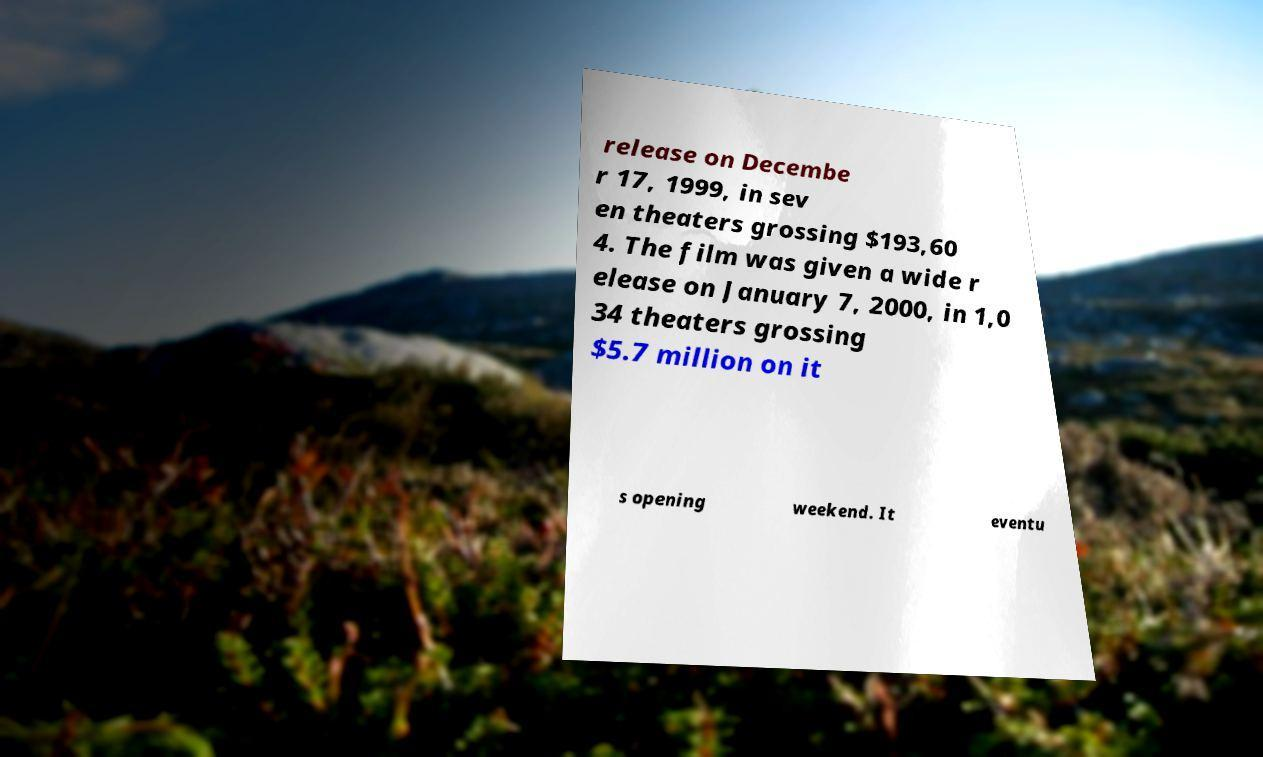What messages or text are displayed in this image? I need them in a readable, typed format. release on Decembe r 17, 1999, in sev en theaters grossing $193,60 4. The film was given a wide r elease on January 7, 2000, in 1,0 34 theaters grossing $5.7 million on it s opening weekend. It eventu 